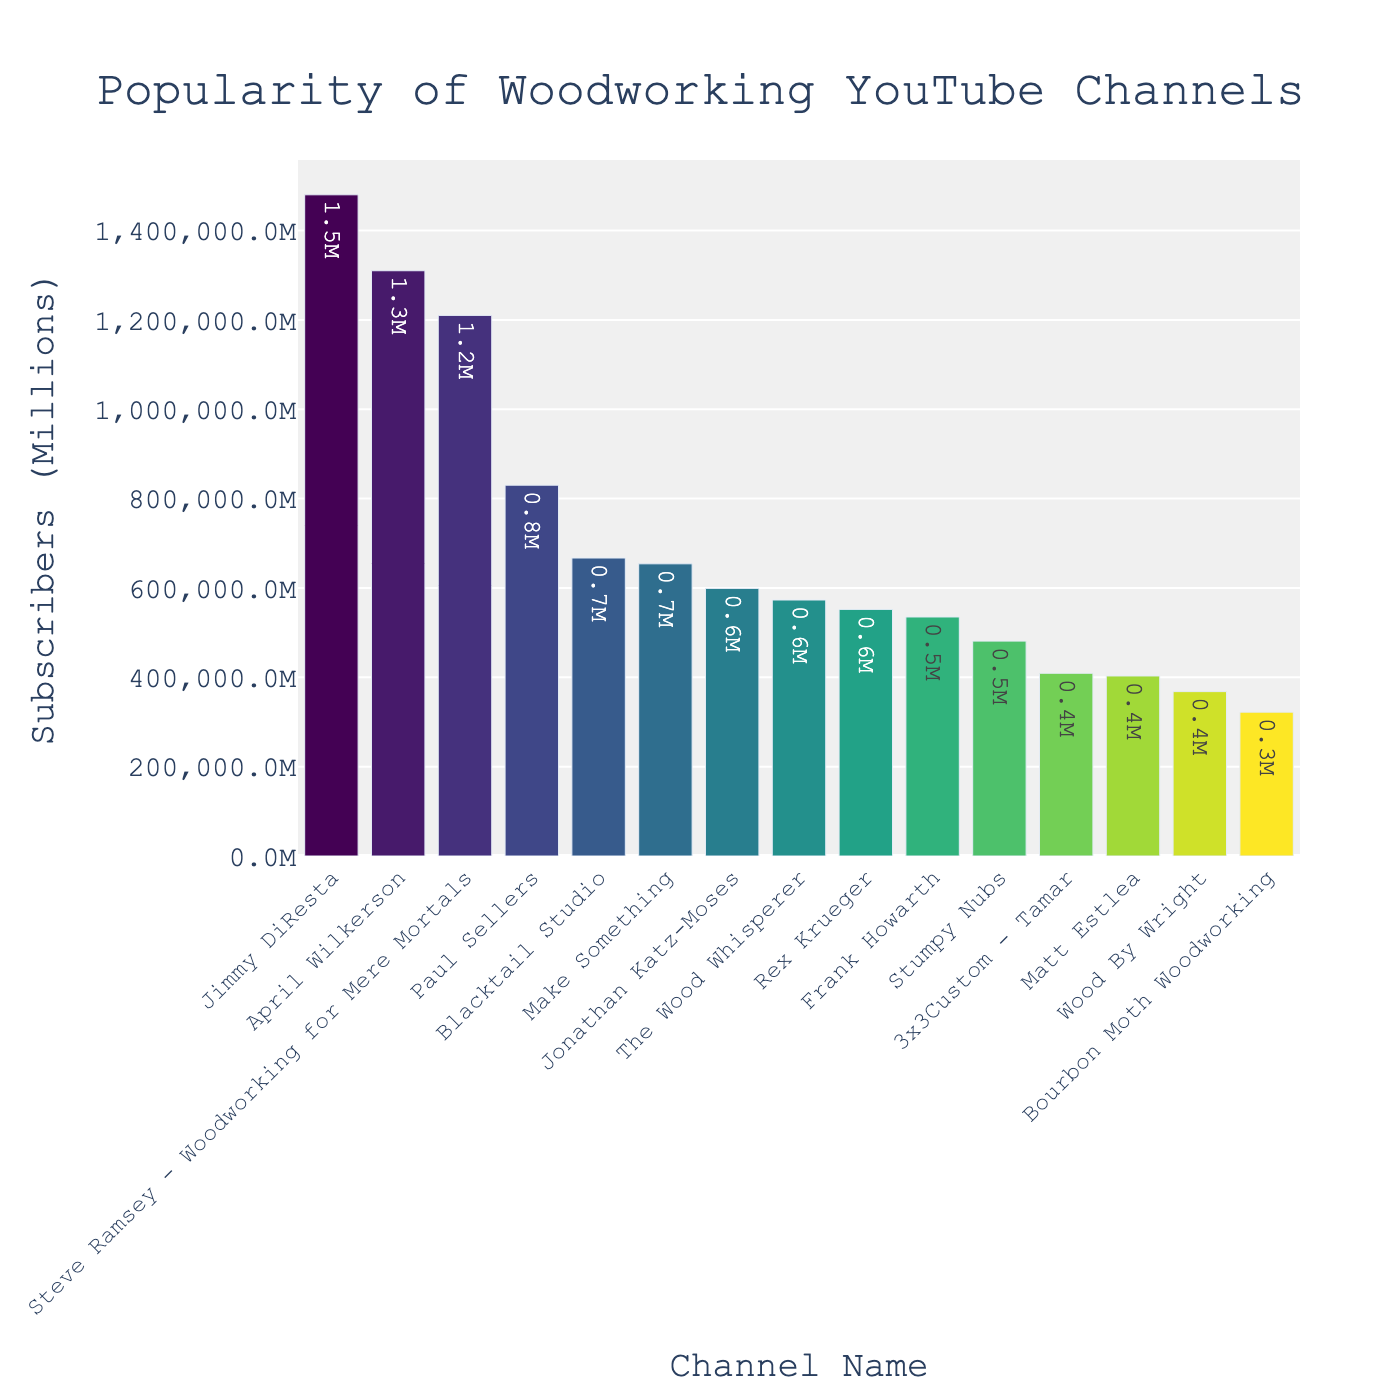Which channel has the highest number of subscribers? Look for the bar that reaches the highest point on the y-axis. This bar corresponds to "Jimmy DiResta," which is the channel with the most subscribers.
Answer: Jimmy DiResta Which channel has fewer subscribers, Frank Howarth or Stumpy Nubs? Compare the heights of the bars representing "Frank Howarth" and "Stumpy Nubs." "Frank Howarth" has a slightly higher bar than "Stumpy Nubs."
Answer: Stumpy Nubs What is the total number of subscribers for the top 3 most popular channels? Add the subscriber counts of the top three channels: "Jimmy DiResta" (1,480,000), "April Wilkerson" (1,310,000), and "Steve Ramsey - Woodworking for Mere Mortals" (1,210,000). 1,480,000 + 1,310,000 + 1,210,000 = 4,000,000.
Answer: 4,000,000 How many channels have more than 1 million subscribers? Count the number of bars that extend above the 1 million mark on the y-axis. The channels are "Jimmy DiResta," "April Wilkerson," and "Steve Ramsey - Woodworking for Mere Mortals," making a total of 3 channels.
Answer: 3 Which channels have subscriber counts between 500,000 and 700,000? Identify the bars that fall within the range of 500,000 to 700,000 subscribers. These channels are "Rex Krueger," "Stumpy Nubs," "Frank Howarth," "Blacktail Studio," "Make Something," and "The Wood Whisperer."
Answer: Rex Krueger, Stumpy Nubs, Frank Howarth, Blacktail Studio, Make Something, The Wood Whisperer What is the difference in subscriber count between "Paul Sellers" and "Jonathan Katz-Moses"? Subtract the subscriber count of "Paul Sellers" (830,000) from "Jonathan Katz-Moses" (599,000). 830,000 - 599,000 = 231,000.
Answer: 231,000 Which channel has the second-lowest number of subscribers? Identify the bar that is the second shortest. The shortest bar is "Bourbon Moth Woodworking" (322,000). The next shortest bar is "Wood By Wright" (368,000).
Answer: Wood By Wright What’s the average number of subscribers for "Paul Sellers," "Rex Krueger," and "Frank Howarth"? Add the subscriber counts for these three channels and divide by 3: (830,000 + 552,000 + 535,000) / 3 = 1,917,000 / 3 = 639,000.
Answer: 639,000 